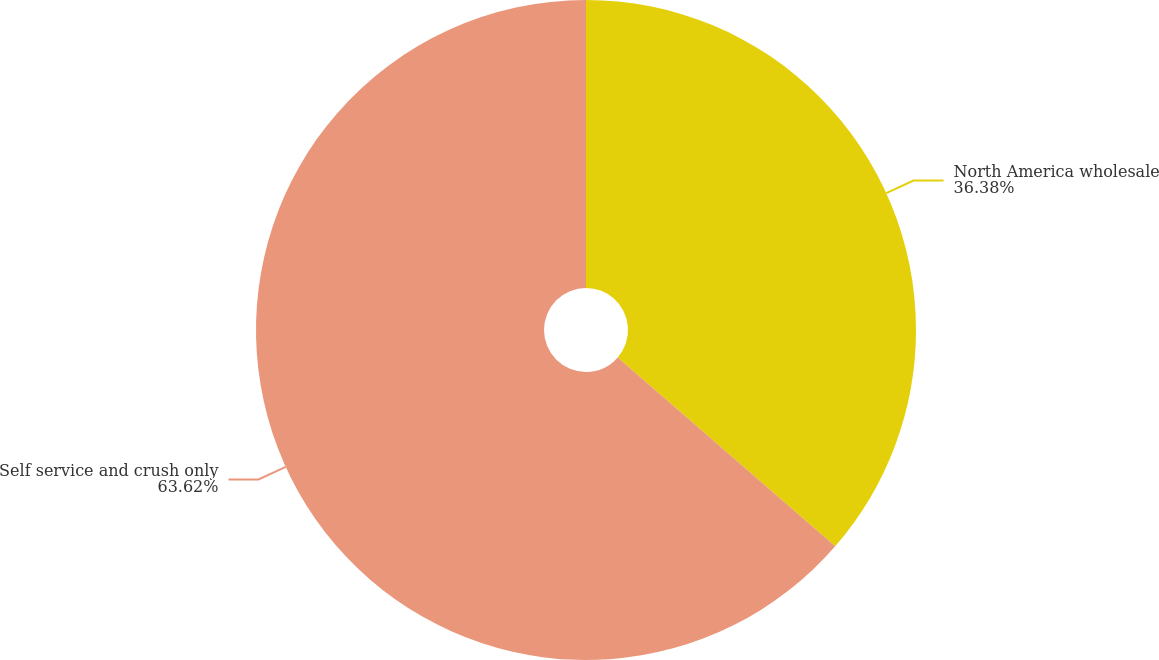Convert chart. <chart><loc_0><loc_0><loc_500><loc_500><pie_chart><fcel>North America wholesale<fcel>Self service and crush only<nl><fcel>36.38%<fcel>63.62%<nl></chart> 